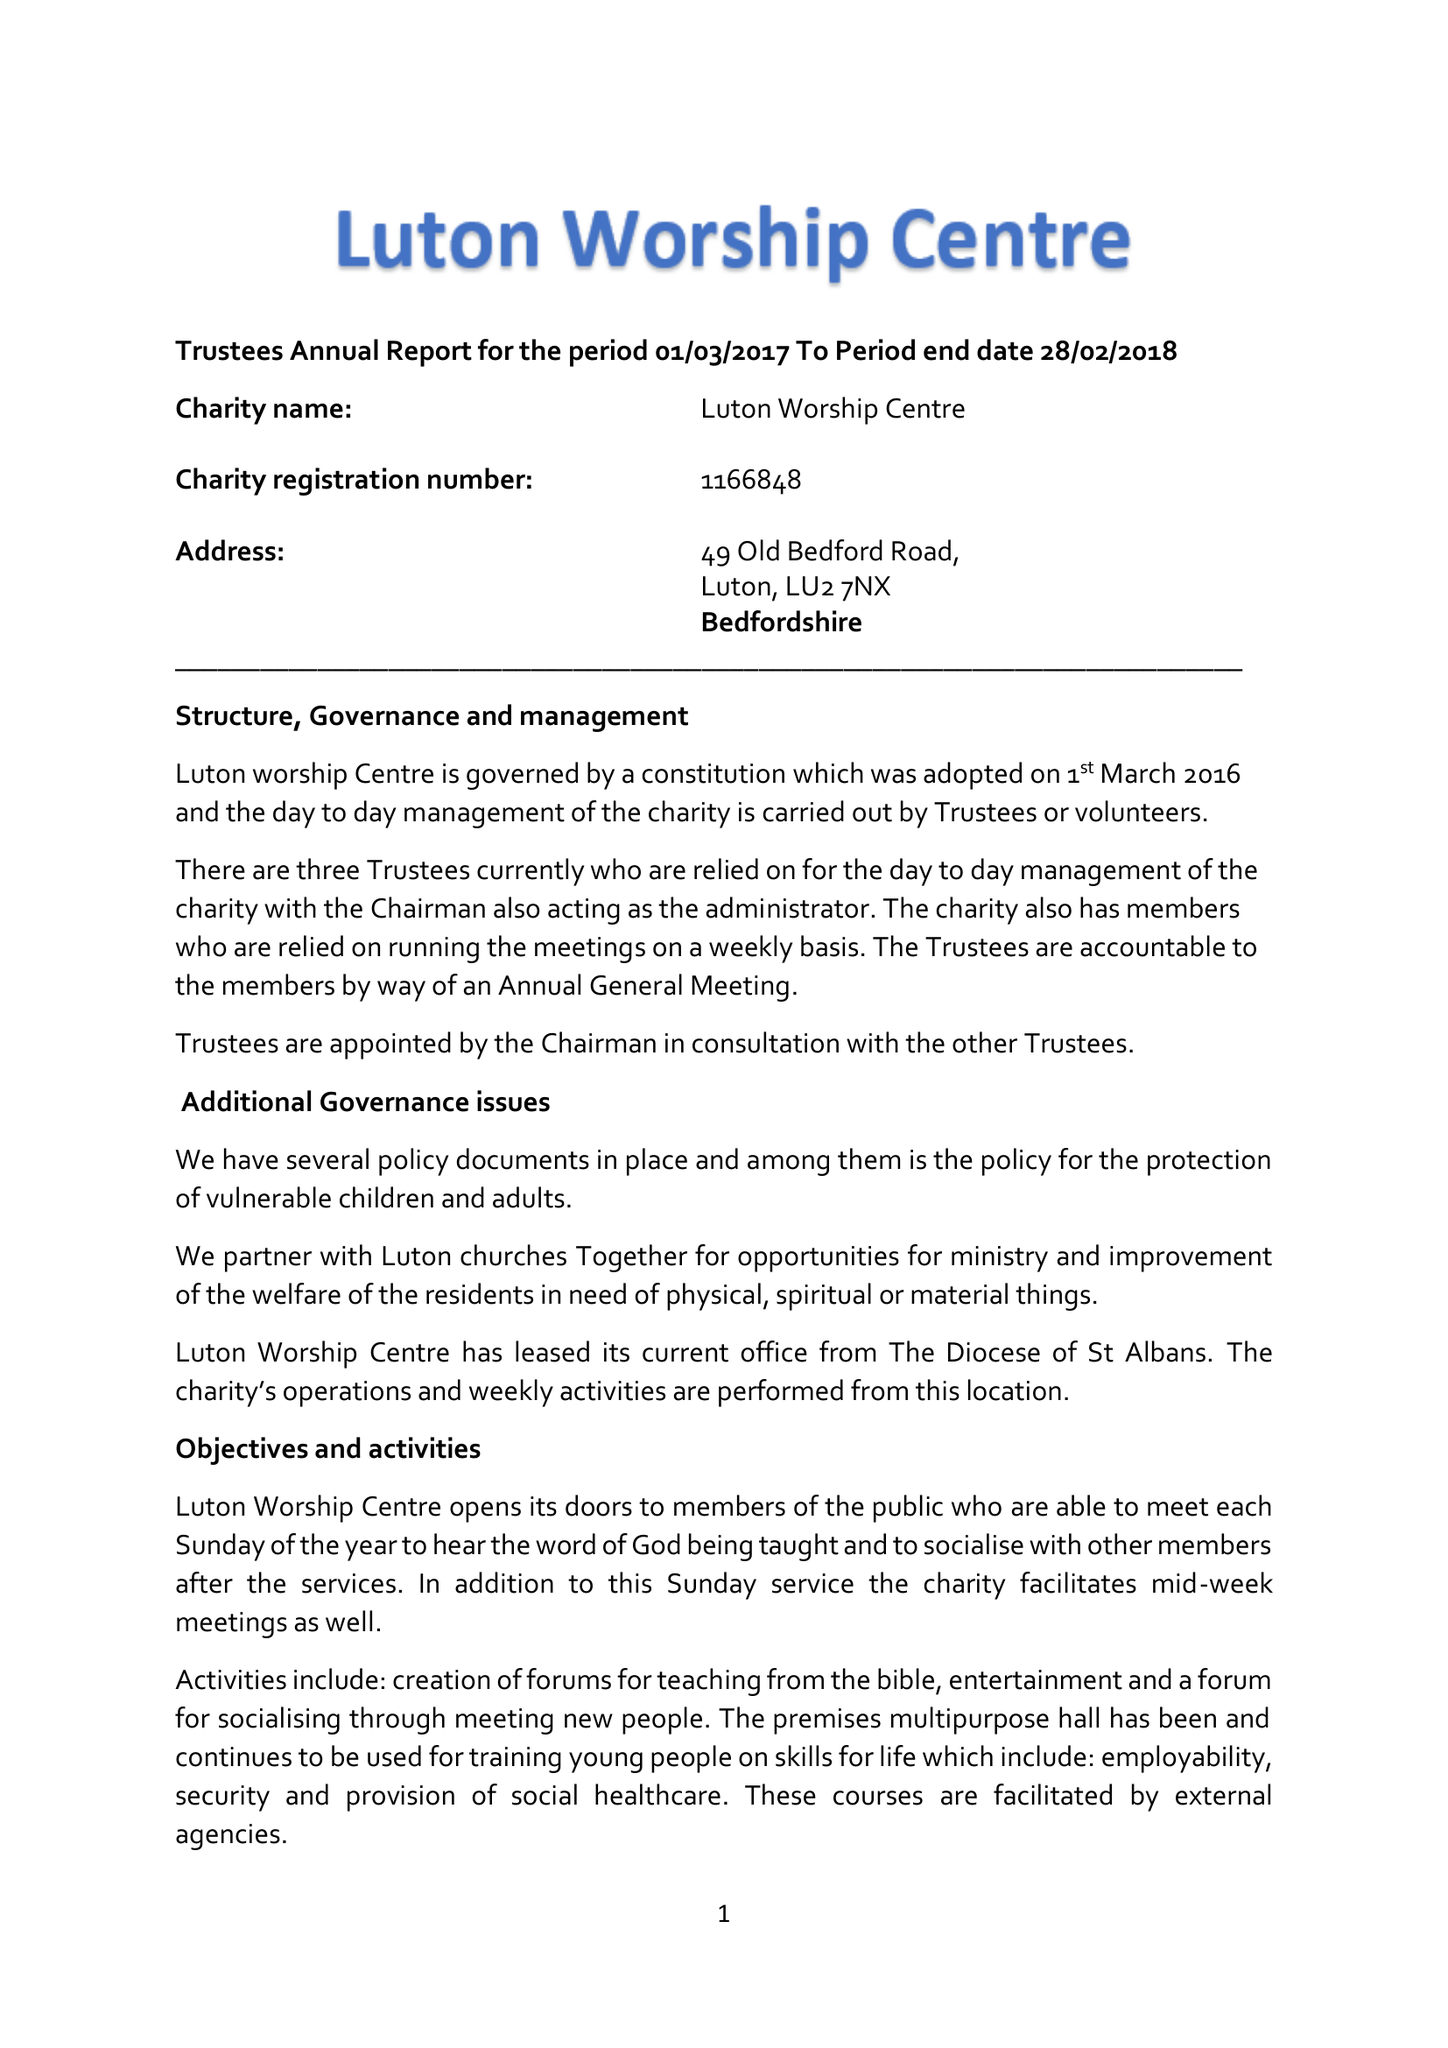What is the value for the charity_number?
Answer the question using a single word or phrase. 1166848 